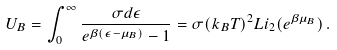Convert formula to latex. <formula><loc_0><loc_0><loc_500><loc_500>U _ { B } = \int _ { 0 } ^ { \infty } \frac { \sigma d \epsilon } { e ^ { \beta ( \epsilon - \mu _ { B } ) } - 1 } = \sigma ( k _ { B } T ) ^ { 2 } L i _ { 2 } ( e ^ { \beta \mu _ { B } } ) \, .</formula> 